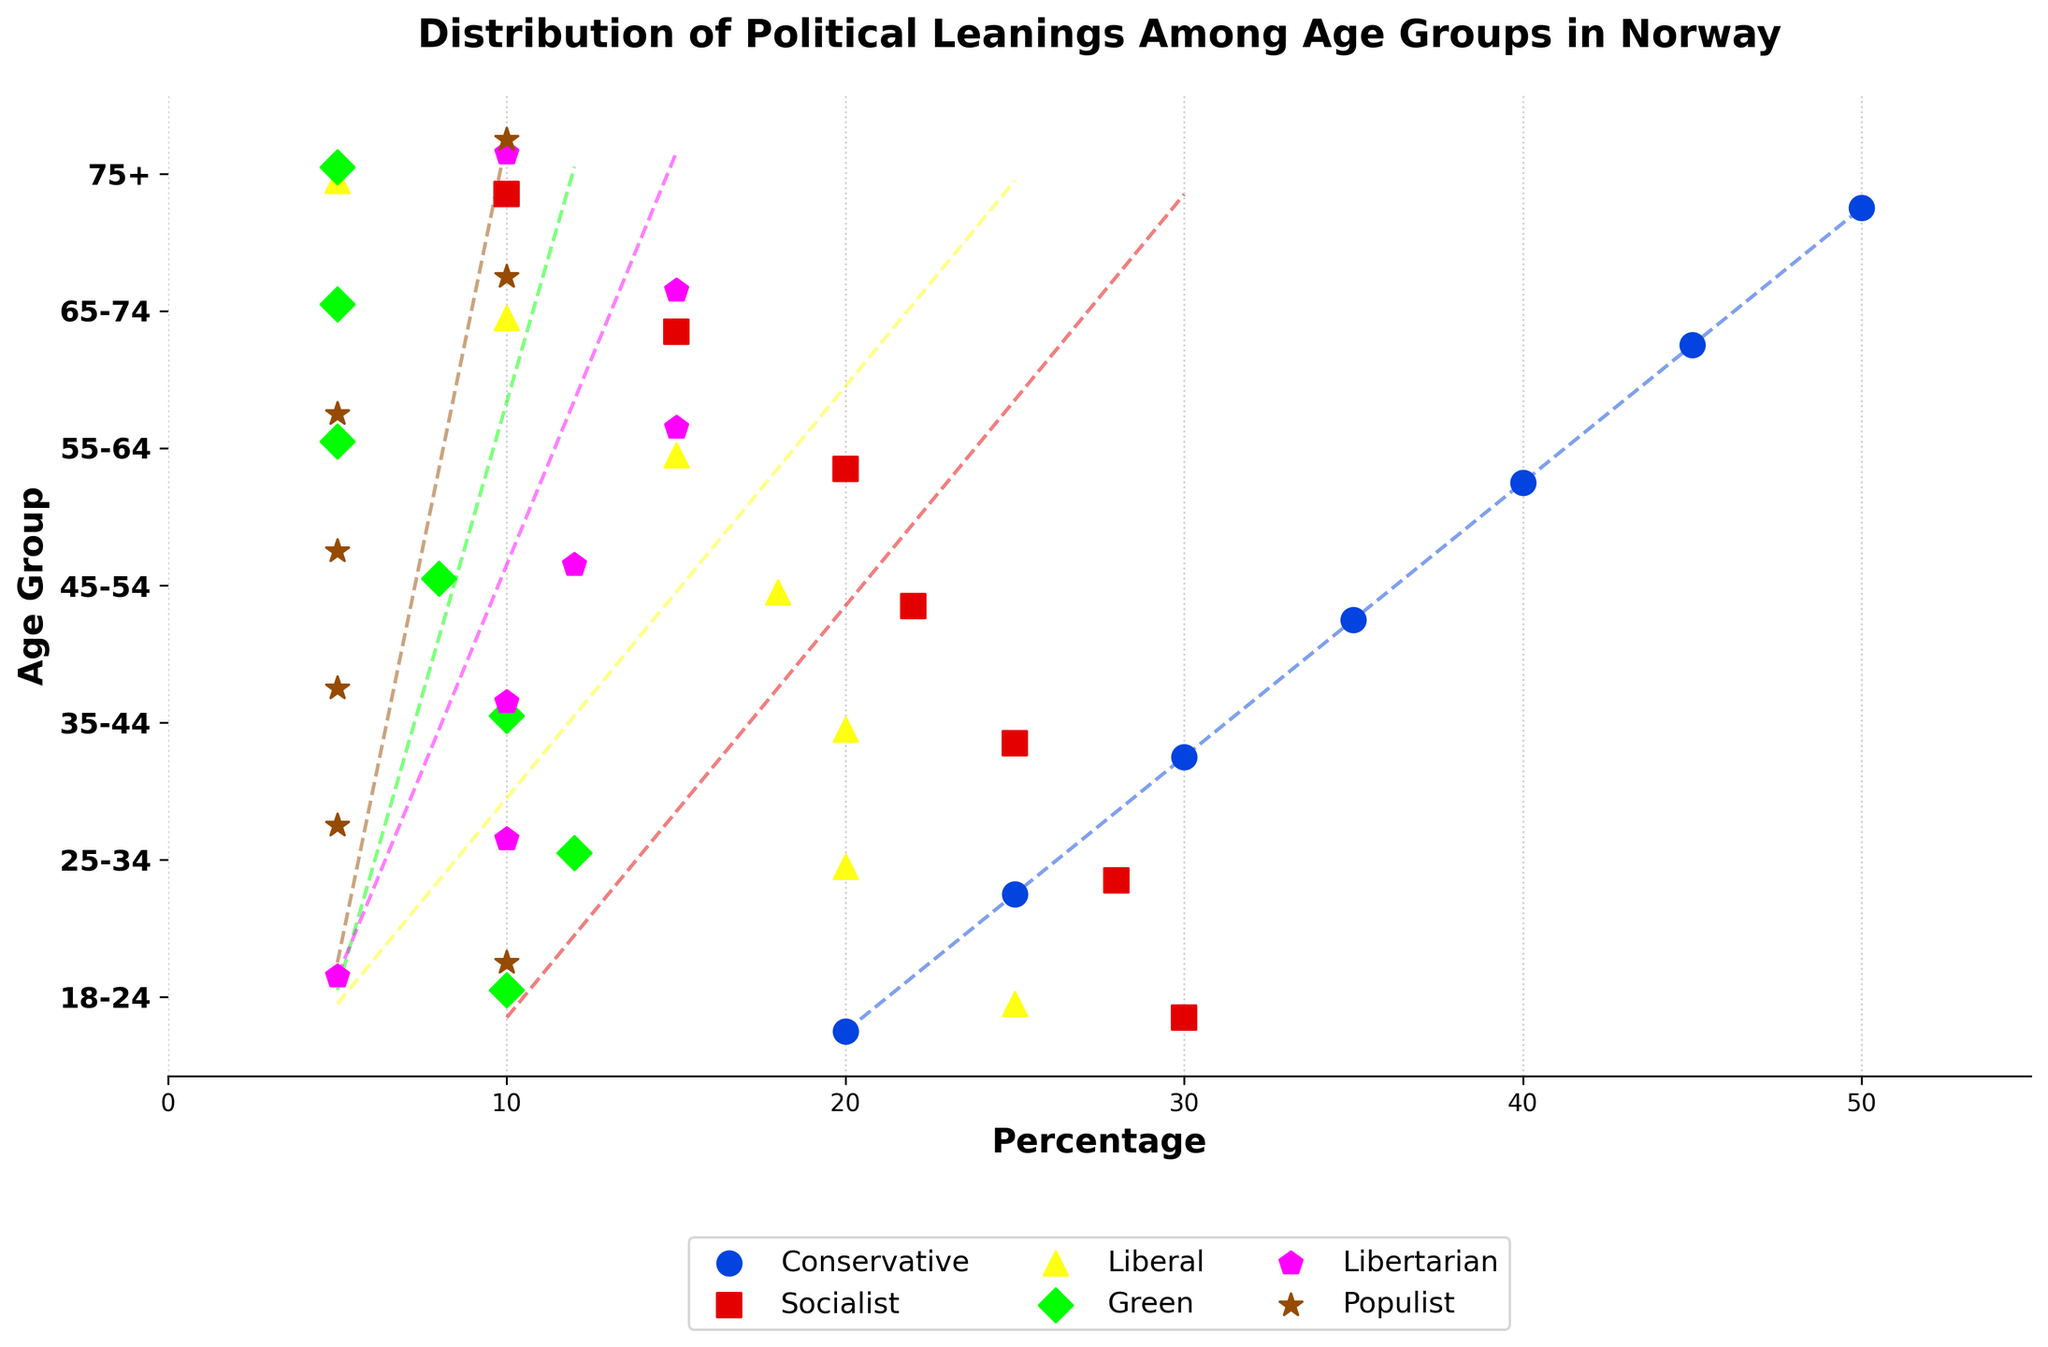What is the title of the plot? The title of the plot is usually displayed at the top of the figure.
Answer: Distribution of Political Leanings Among Age Groups in Norway Which political party has the highest percentage among the 75+ age group? The 75+ age group shows a dot plot with the Conservative party having the highest percentage among this age group.
Answer: Conservative What percentage of 25-34 year olds support the Socialist party? The dot for the Socialist party in the 25-34 age group shows a percentage of 28%.
Answer: 28% How does Conservative support change from the 18-24 age group to the 75+ age group? Looking at the dots representing the Conservative party across the age groups, the percentage increases from 20% in 18-24 to 50% in 75+. The changes are: 20%, 25%, 30%, 35%, 40%, 45%, and 50%.
Answer: It increases Which two political parties share the same percentage of support among the 35-44 age group? In the 35-44 age group, examine the dots and find parties with the same percentage; Socialist and Liberal both have 20%.
Answer: Socialist and Liberal What is the difference in support for the Green party between the 18-24 age group and the 55-64 age group? The Green party has 10% support among the 18-24 age group and 5% among the 55-64 age group. The difference is calculated as 10% - 5% = 5%.
Answer: 5% Which age group has the lowest support for the Populist party? By comparing the dot positions for the Populist party across all age groups, the 25-34, 35-44, 45-54, and 55-64 age groups all show the lowest support at 5%.
Answer: 25-34, 35-44, 45-54, and 55-64 How many political parties consistently have increasing support with age? Analyze the plot for each political party's support from the youngest to the oldest age group. Only the Conservative party shows a consistent increase.
Answer: One (Conservative) Which party has a visible decline in support across most age groups? By visually inspecting the trend lines, the Socialist party shows a clear decrease in support as age increases.
Answer: Socialist What percentage of 55-64 year olds support the Libertarian party, and how does it compare with the 75+ age group? The 55-64 age group shows 15% for the Libertarian party and the 75+ age group shows 10%. Compare these as 15% - 10% = 5%, so it is 5% higher among 55-64 year olds.
Answer: 15% (5% higher than 75+) 